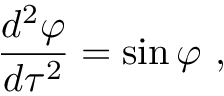Convert formula to latex. <formula><loc_0><loc_0><loc_500><loc_500>{ \frac { d ^ { 2 } \varphi } { d \tau ^ { 2 } } } = \sin \varphi \ ,</formula> 